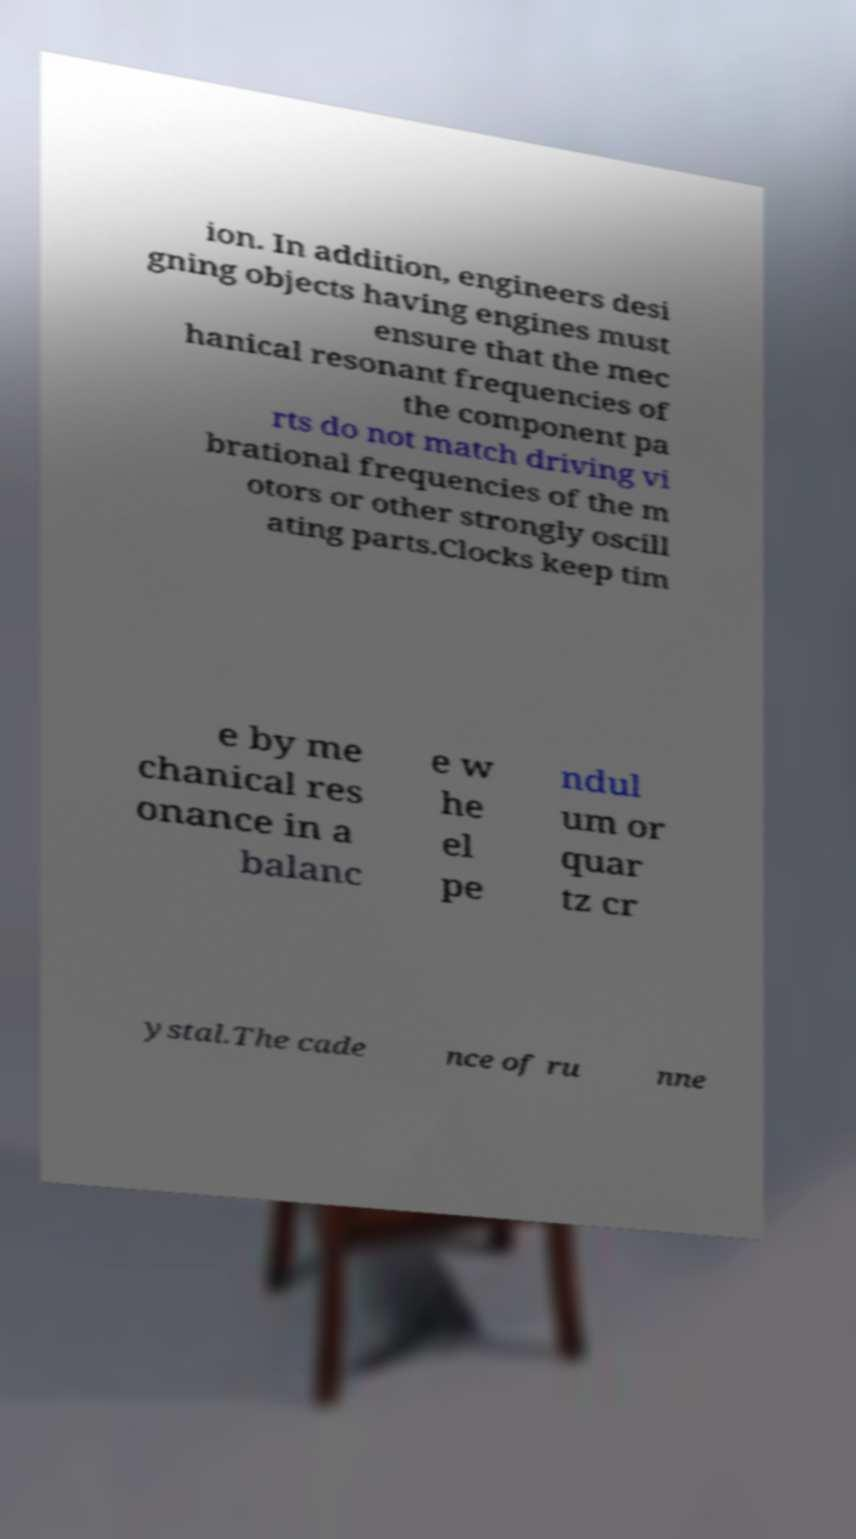Could you assist in decoding the text presented in this image and type it out clearly? ion. In addition, engineers desi gning objects having engines must ensure that the mec hanical resonant frequencies of the component pa rts do not match driving vi brational frequencies of the m otors or other strongly oscill ating parts.Clocks keep tim e by me chanical res onance in a balanc e w he el pe ndul um or quar tz cr ystal.The cade nce of ru nne 